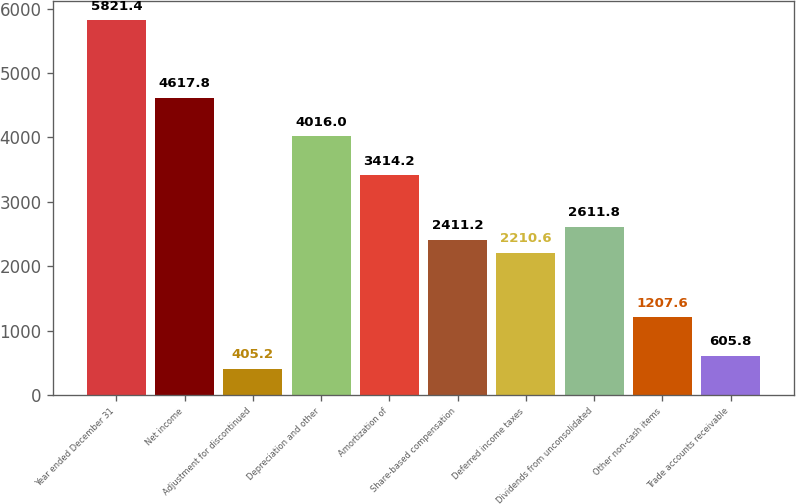<chart> <loc_0><loc_0><loc_500><loc_500><bar_chart><fcel>Year ended December 31<fcel>Net income<fcel>Adjustment for discontinued<fcel>Depreciation and other<fcel>Amortization of<fcel>Share-based compensation<fcel>Deferred income taxes<fcel>Dividends from unconsolidated<fcel>Other non-cash items<fcel>Trade accounts receivable<nl><fcel>5821.4<fcel>4617.8<fcel>405.2<fcel>4016<fcel>3414.2<fcel>2411.2<fcel>2210.6<fcel>2611.8<fcel>1207.6<fcel>605.8<nl></chart> 